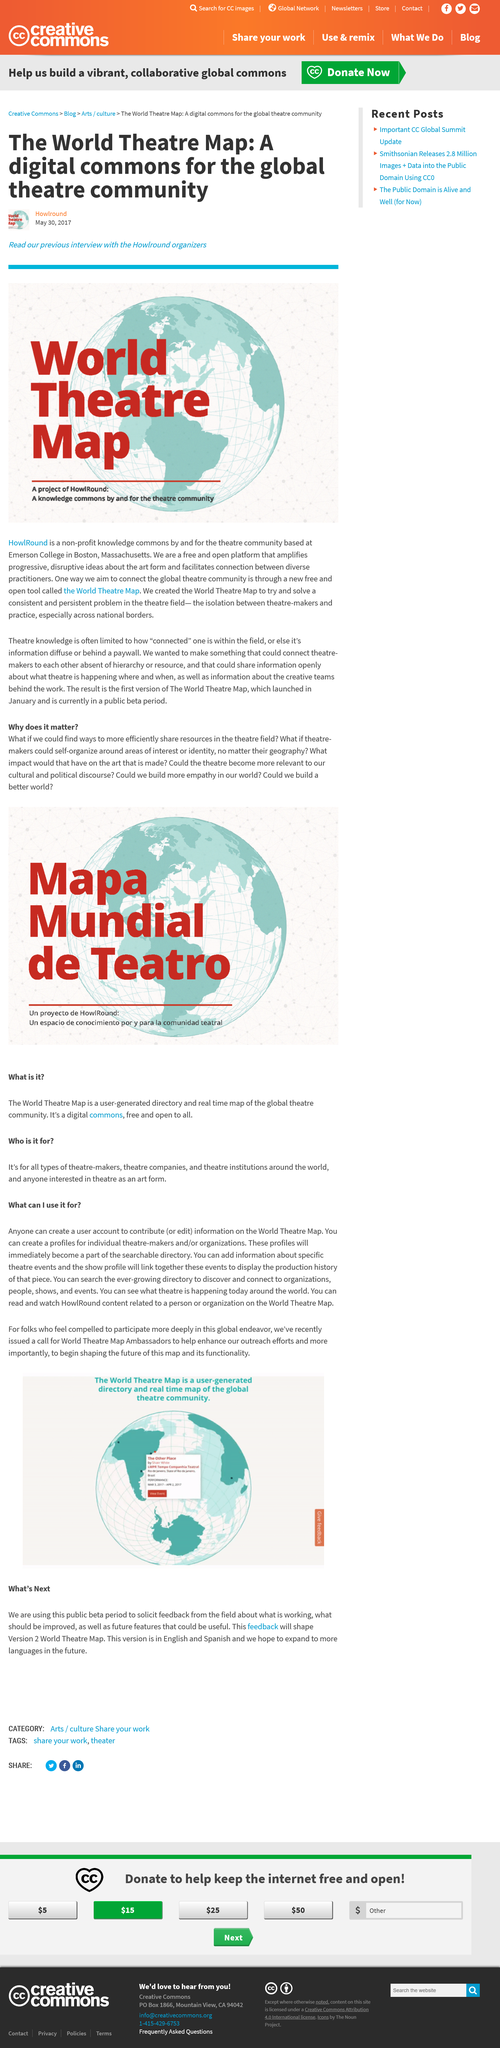Identify some key points in this picture. The World Theatre Map is a comprehensive global initiative that covers various aspects of theatre and performance around the world. The first question asked was 'What if we could find ways to more efficiently share resources in the theatre field?' The World Theatre Map aims to address the isolation that exists between theatre-makers and their practices, especially across national borders. This initiative hopes to foster collaboration and connectivity in the theatre field to promote cultural exchange and artistic growth. A World Theatre Map is a user-generated directory and real-time map of the global theatre community that enables users to discover and connect with organizations, people, shows, and events. I have learned that the organizers of "HowlRound" are located at Emerson College in Boston, Massachusetts. 